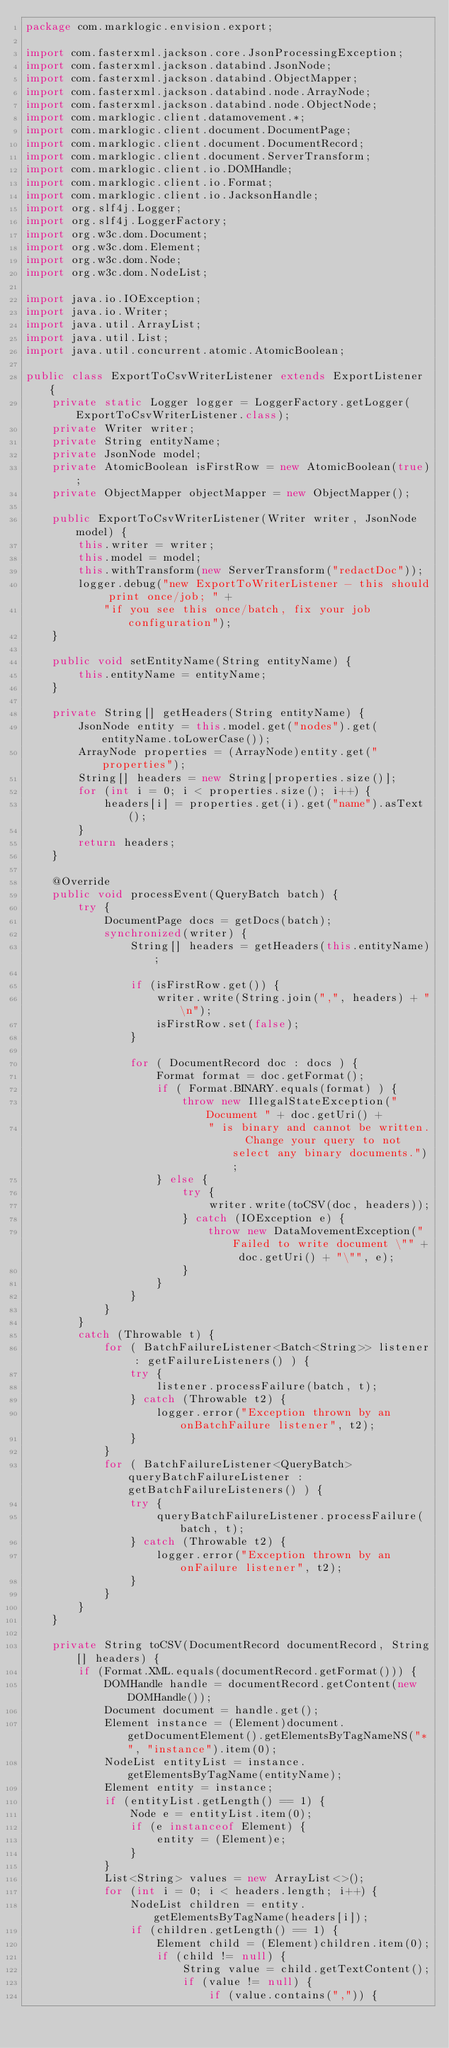Convert code to text. <code><loc_0><loc_0><loc_500><loc_500><_Java_>package com.marklogic.envision.export;

import com.fasterxml.jackson.core.JsonProcessingException;
import com.fasterxml.jackson.databind.JsonNode;
import com.fasterxml.jackson.databind.ObjectMapper;
import com.fasterxml.jackson.databind.node.ArrayNode;
import com.fasterxml.jackson.databind.node.ObjectNode;
import com.marklogic.client.datamovement.*;
import com.marklogic.client.document.DocumentPage;
import com.marklogic.client.document.DocumentRecord;
import com.marklogic.client.document.ServerTransform;
import com.marklogic.client.io.DOMHandle;
import com.marklogic.client.io.Format;
import com.marklogic.client.io.JacksonHandle;
import org.slf4j.Logger;
import org.slf4j.LoggerFactory;
import org.w3c.dom.Document;
import org.w3c.dom.Element;
import org.w3c.dom.Node;
import org.w3c.dom.NodeList;

import java.io.IOException;
import java.io.Writer;
import java.util.ArrayList;
import java.util.List;
import java.util.concurrent.atomic.AtomicBoolean;

public class ExportToCsvWriterListener extends ExportListener {
	private static Logger logger = LoggerFactory.getLogger(ExportToCsvWriterListener.class);
	private Writer writer;
	private String entityName;
	private JsonNode model;
	private AtomicBoolean isFirstRow = new AtomicBoolean(true);
	private ObjectMapper objectMapper = new ObjectMapper();

	public ExportToCsvWriterListener(Writer writer, JsonNode model) {
		this.writer = writer;
		this.model = model;
		this.withTransform(new ServerTransform("redactDoc"));
		logger.debug("new ExportToWriterListener - this should print once/job; " +
			"if you see this once/batch, fix your job configuration");
	}

	public void setEntityName(String entityName) {
		this.entityName = entityName;
	}

	private String[] getHeaders(String entityName) {
		JsonNode entity = this.model.get("nodes").get(entityName.toLowerCase());
		ArrayNode properties = (ArrayNode)entity.get("properties");
		String[] headers = new String[properties.size()];
		for (int i = 0; i < properties.size(); i++) {
			headers[i] = properties.get(i).get("name").asText();
		}
		return headers;
	}

	@Override
	public void processEvent(QueryBatch batch) {
		try {
			DocumentPage docs = getDocs(batch);
			synchronized(writer) {
				String[] headers = getHeaders(this.entityName);

				if (isFirstRow.get()) {
					writer.write(String.join(",", headers) + "\n");
					isFirstRow.set(false);
				}

				for ( DocumentRecord doc : docs ) {
					Format format = doc.getFormat();
					if ( Format.BINARY.equals(format) ) {
						throw new IllegalStateException("Document " + doc.getUri() +
							" is binary and cannot be written.  Change your query to not select any binary documents.");
					} else {
						try {
							writer.write(toCSV(doc, headers));
						} catch (IOException e) {
							throw new DataMovementException("Failed to write document \"" + doc.getUri() + "\"", e);
						}
					}
				}
			}
		}
		catch (Throwable t) {
			for ( BatchFailureListener<Batch<String>> listener : getFailureListeners() ) {
				try {
					listener.processFailure(batch, t);
				} catch (Throwable t2) {
					logger.error("Exception thrown by an onBatchFailure listener", t2);
				}
			}
			for ( BatchFailureListener<QueryBatch> queryBatchFailureListener : getBatchFailureListeners() ) {
				try {
					queryBatchFailureListener.processFailure(batch, t);
				} catch (Throwable t2) {
					logger.error("Exception thrown by an onFailure listener", t2);
				}
			}
		}
	}

	private String toCSV(DocumentRecord documentRecord, String[] headers) {
		if (Format.XML.equals(documentRecord.getFormat())) {
			DOMHandle handle = documentRecord.getContent(new DOMHandle());
			Document document = handle.get();
			Element instance = (Element)document.getDocumentElement().getElementsByTagNameNS("*", "instance").item(0);
			NodeList entityList = instance.getElementsByTagName(entityName);
			Element entity = instance;
			if (entityList.getLength() == 1) {
				Node e = entityList.item(0);
				if (e instanceof Element) {
					entity = (Element)e;
				}
			}
			List<String> values = new ArrayList<>();
			for (int i = 0; i < headers.length; i++) {
				NodeList children = entity.getElementsByTagName(headers[i]);
				if (children.getLength() == 1) {
					Element child = (Element)children.item(0);
					if (child != null) {
						String value = child.getTextContent();
						if (value != null) {
							if (value.contains(",")) {</code> 